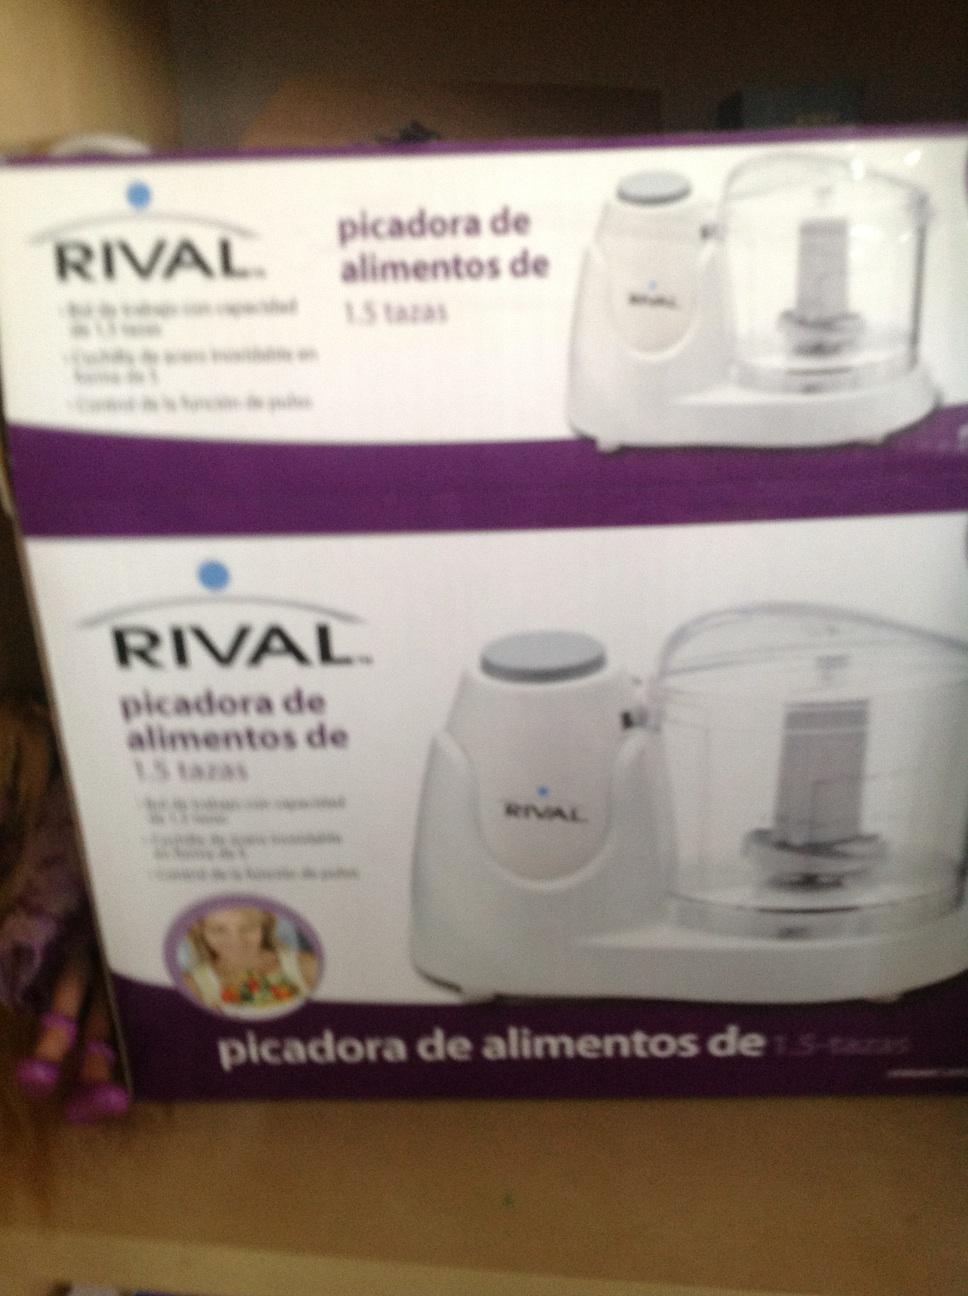Imagine a futuristic version of this product. How would it work? Imagine a futuristic version of this RIVAL food chopper. It could be a smart kitchen appliance integrated with AI technology. You would simply place your ingredients inside, and using voice commands or a smartphone app, you could specify the exact consistency and type of chop you want. It could automatically adjust speed and chopping time, and might even have features like self-cleaning or integration with other smart kitchen devices to suggest recipes based on the ingredients you have. 